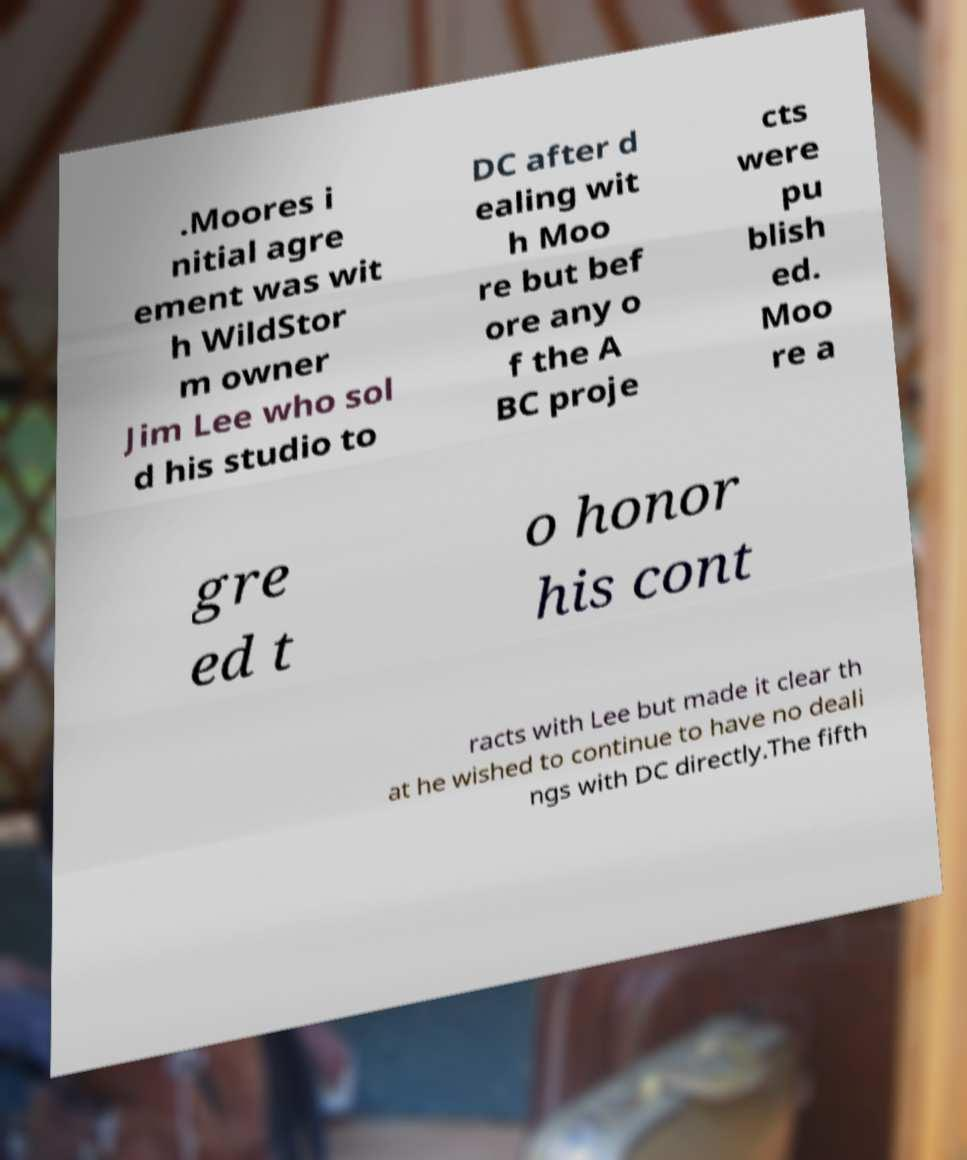Can you accurately transcribe the text from the provided image for me? .Moores i nitial agre ement was wit h WildStor m owner Jim Lee who sol d his studio to DC after d ealing wit h Moo re but bef ore any o f the A BC proje cts were pu blish ed. Moo re a gre ed t o honor his cont racts with Lee but made it clear th at he wished to continue to have no deali ngs with DC directly.The fifth 